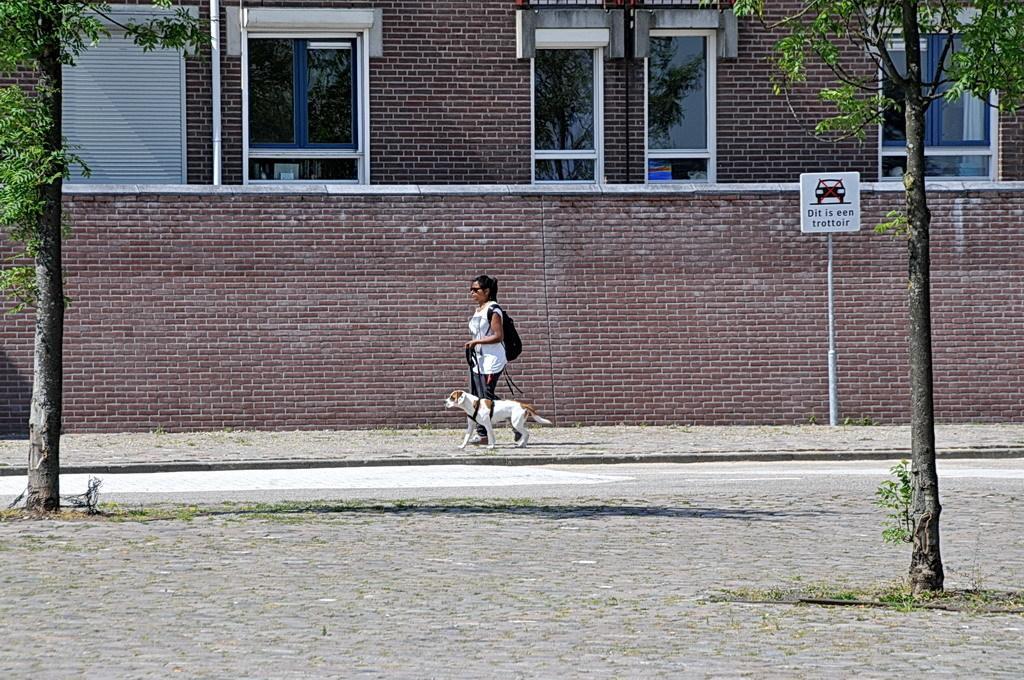Can you describe this image briefly? Here we can see a woman holding a belt which is tied to a dog and she wore a bag. There is a board attached to a pole. Here we can see trees, windows, road, and a building. 